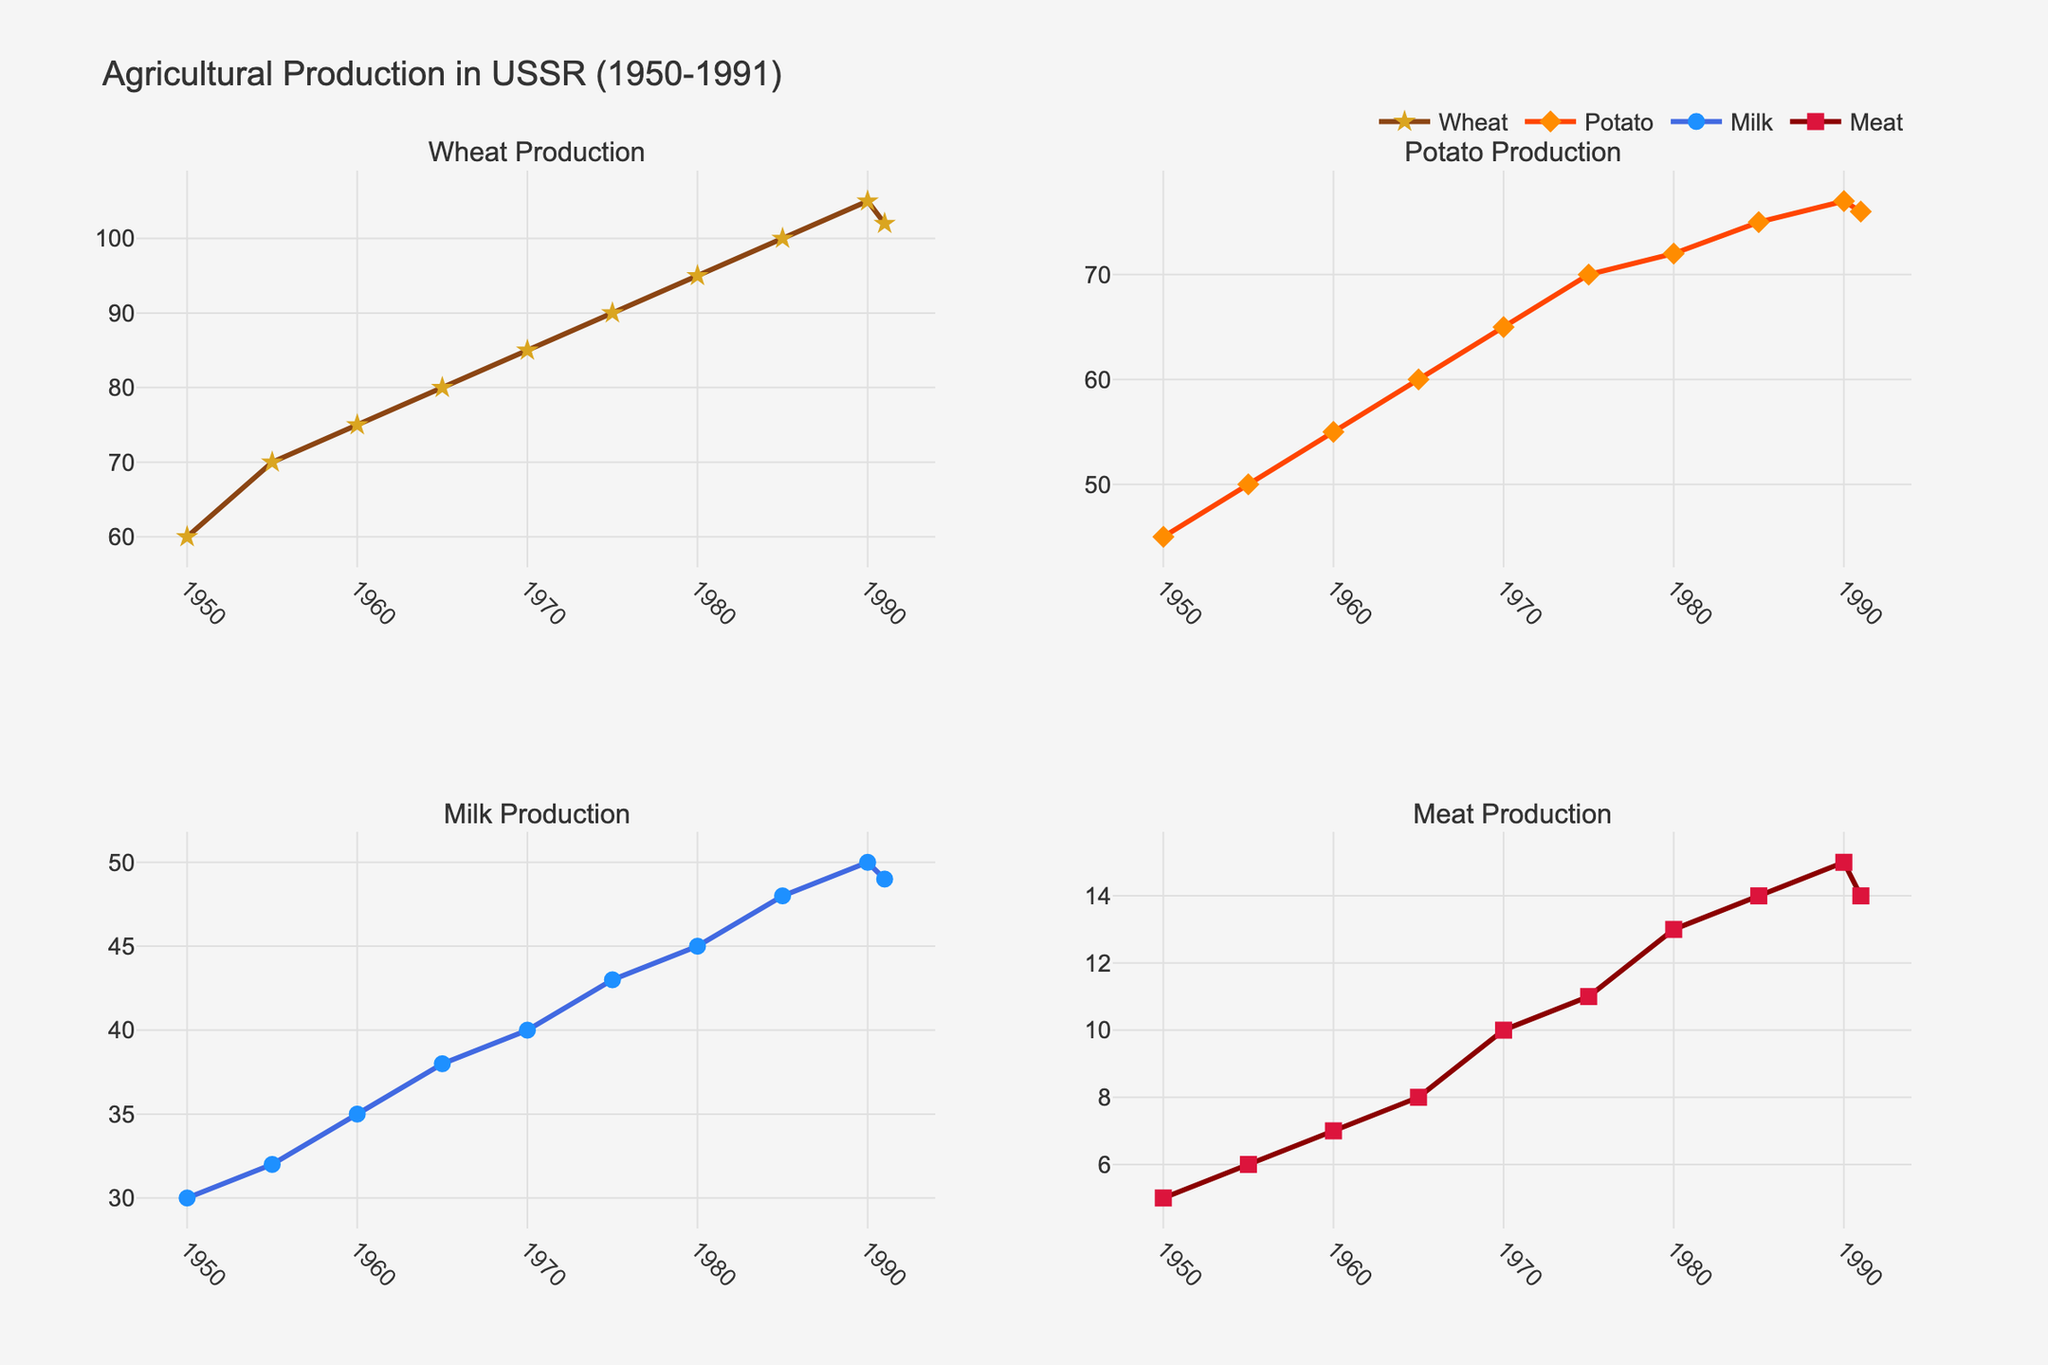what is the overall trend in wheat production from 1950 to 1991? Wheat production shows a consistent upward trend from 1950 to 1990, increasing from 60 million tons to 105 million tons. It slightly decreases in 1991 to 102 million tons.
Answer: Upward trend with a slight decrease in 1991 how much did potato production increase between 1950 and 1990? Potato production increased from 45 million tons in 1950 to 77 million tons in 1990. The increase can be calculated as 77 - 45.
Answer: 32 million tons compare the production levels of meat and milk in 1991. which was higher? In 1991, milk production was 49 million tons and meat production was 14 million tons. Since 49 is greater than 14, milk production was higher.
Answer: Milk production what year saw the highest production of wheat? By looking at the plot, the production of wheat peaked in 1990 at 105 million tons.
Answer: 1990 calculate the average meat production over the entire period. The production values of meat (in million tons) over the years are: 5, 6, 7, 8, 10, 11, 13, 14, 15, and 14. Summing them gives 103, and there are 10 years. The average is 103 / 10.
Answer: 10.3 million tons in which decade did milk production see the greatest increase? Examining the milk production data from each decade: from 1950 to 1960, it increased by 5 million tons; from 1960 to 1970, by 5 million tons; from 1970 to 1980, by 5 million tons; from 1980 to 1990, by 5 million tons. All these decades show an equal increase of 5 million tons each.
Answer: Each decade saw an equal increase of 5 million tons was there ever a period when potato production decreased? From examining the plot, potato production peaked at 77 million tons in 1990 and then slightly decreased to 76 million tons in 1991.
Answer: Yes, between 1990 and 1991 what is the ratio of wheat to meat production in 1980? In 1980, wheat production was 95 million tons, and meat production was 13 million tons. The ratio can be calculated as 95 / 13.
Answer: About 7.31 how does the trend of milk production compare to potato production from 1950 to 1991? Both milk and potato production exhibit an overall increasing trend from 1950 to 1990. Milk production increased from 30 to 50 million tons, while potato production increased from 45 to 77 million tons. However, both see a slight decrease in 1991.
Answer: Both trends are similar, increasing from 1950 to 1990 and slightly decreasing in 1991 